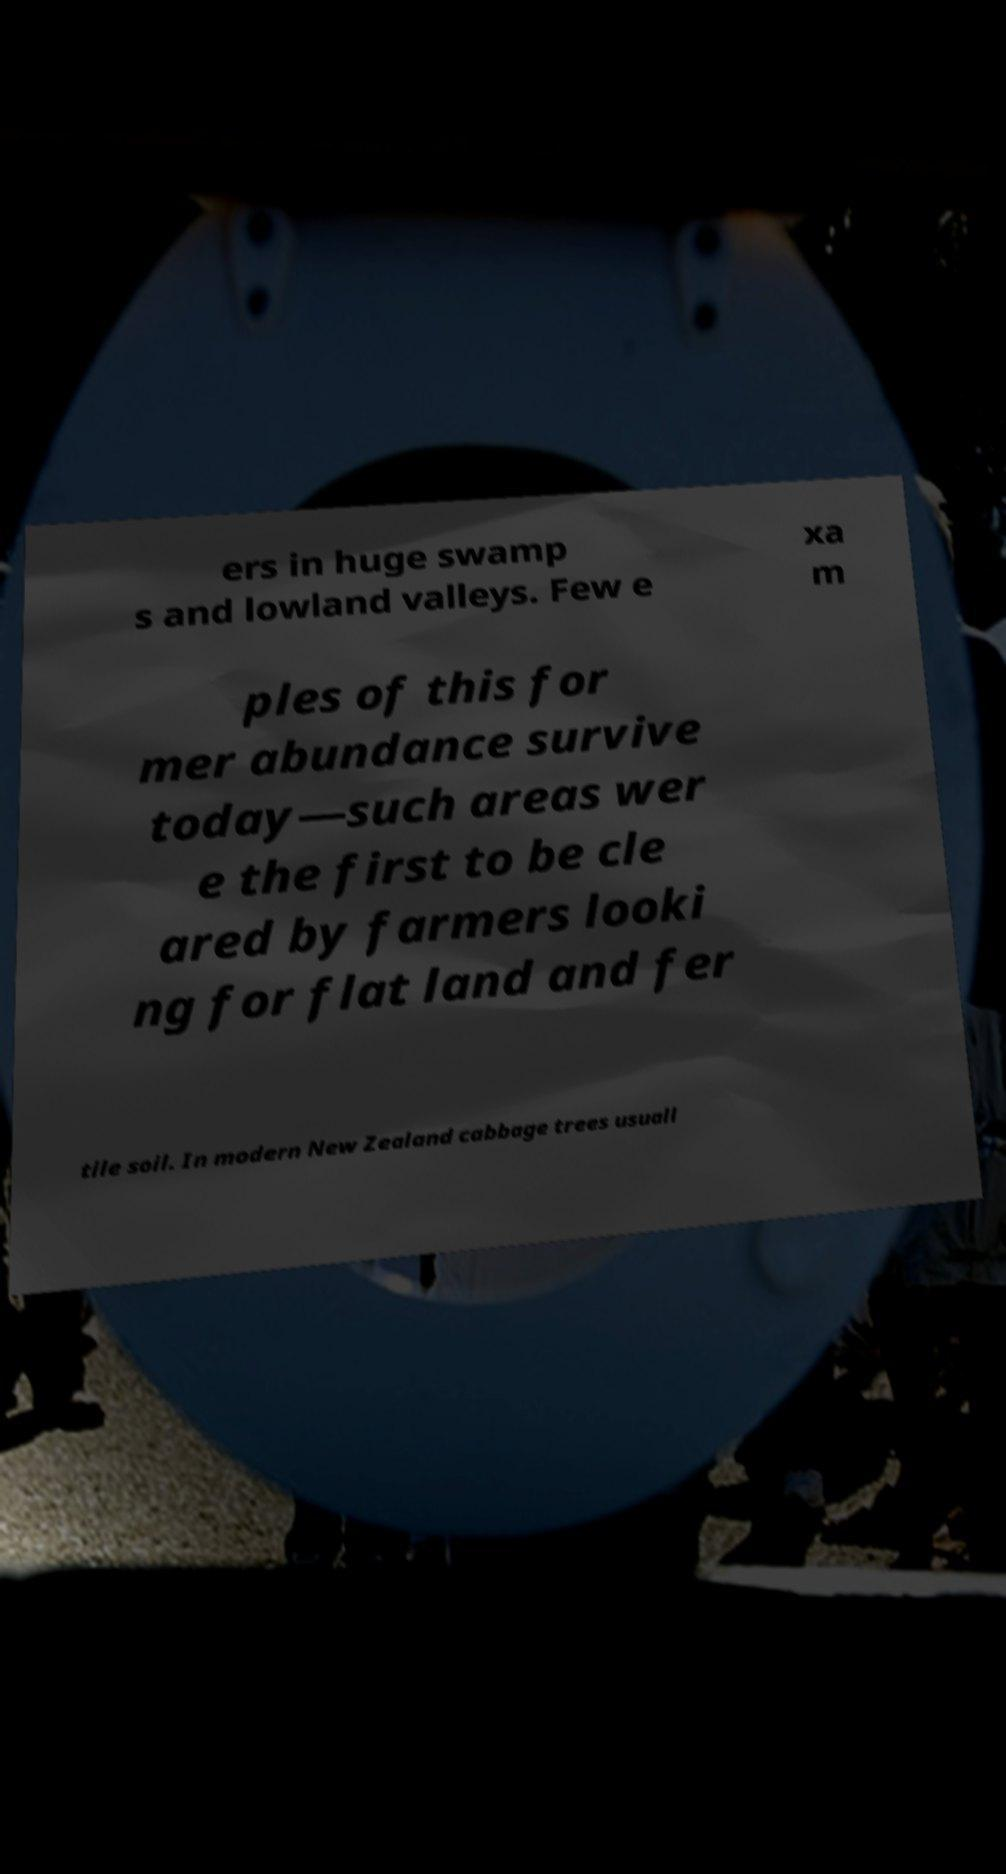There's text embedded in this image that I need extracted. Can you transcribe it verbatim? ers in huge swamp s and lowland valleys. Few e xa m ples of this for mer abundance survive today—such areas wer e the first to be cle ared by farmers looki ng for flat land and fer tile soil. In modern New Zealand cabbage trees usuall 